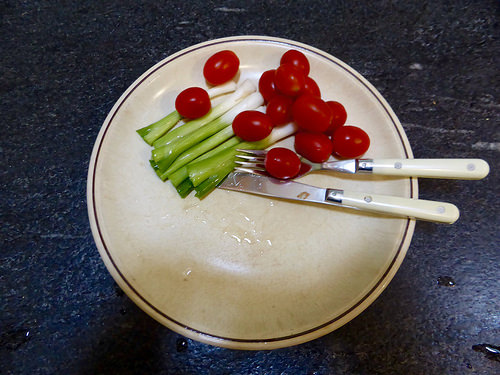<image>
Is there a tomato on the tomato? Yes. Looking at the image, I can see the tomato is positioned on top of the tomato, with the tomato providing support. 